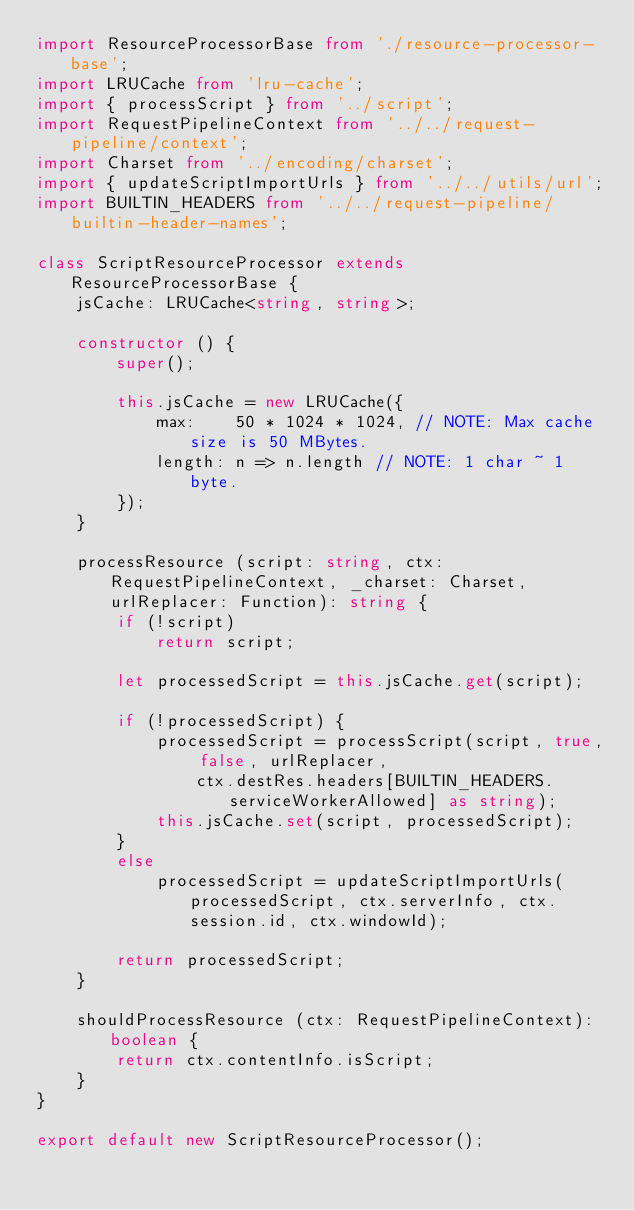Convert code to text. <code><loc_0><loc_0><loc_500><loc_500><_TypeScript_>import ResourceProcessorBase from './resource-processor-base';
import LRUCache from 'lru-cache';
import { processScript } from '../script';
import RequestPipelineContext from '../../request-pipeline/context';
import Charset from '../encoding/charset';
import { updateScriptImportUrls } from '../../utils/url';
import BUILTIN_HEADERS from '../../request-pipeline/builtin-header-names';

class ScriptResourceProcessor extends ResourceProcessorBase {
    jsCache: LRUCache<string, string>;

    constructor () {
        super();

        this.jsCache = new LRUCache({
            max:    50 * 1024 * 1024, // NOTE: Max cache size is 50 MBytes.
            length: n => n.length // NOTE: 1 char ~ 1 byte.
        });
    }

    processResource (script: string, ctx: RequestPipelineContext, _charset: Charset, urlReplacer: Function): string {
        if (!script)
            return script;

        let processedScript = this.jsCache.get(script);

        if (!processedScript) {
            processedScript = processScript(script, true, false, urlReplacer,
                ctx.destRes.headers[BUILTIN_HEADERS.serviceWorkerAllowed] as string);
            this.jsCache.set(script, processedScript);
        }
        else
            processedScript = updateScriptImportUrls(processedScript, ctx.serverInfo, ctx.session.id, ctx.windowId);

        return processedScript;
    }

    shouldProcessResource (ctx: RequestPipelineContext): boolean {
        return ctx.contentInfo.isScript;
    }
}

export default new ScriptResourceProcessor();
</code> 